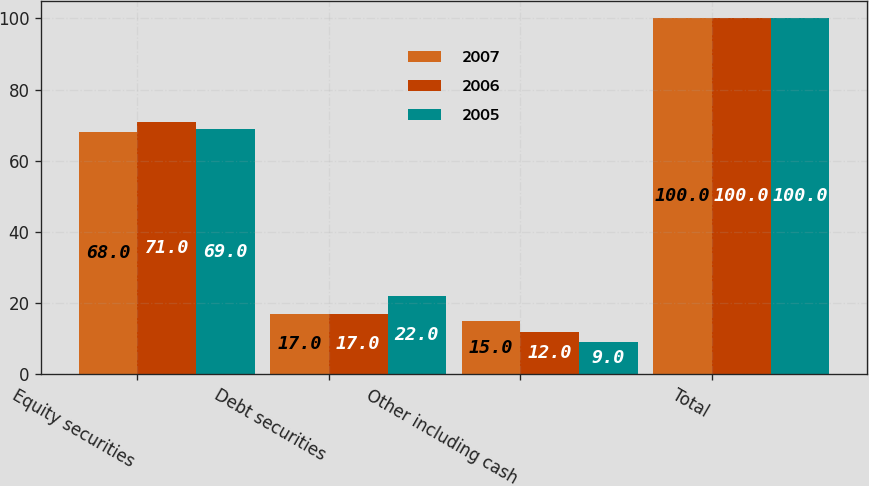<chart> <loc_0><loc_0><loc_500><loc_500><stacked_bar_chart><ecel><fcel>Equity securities<fcel>Debt securities<fcel>Other including cash<fcel>Total<nl><fcel>2007<fcel>68<fcel>17<fcel>15<fcel>100<nl><fcel>2006<fcel>71<fcel>17<fcel>12<fcel>100<nl><fcel>2005<fcel>69<fcel>22<fcel>9<fcel>100<nl></chart> 